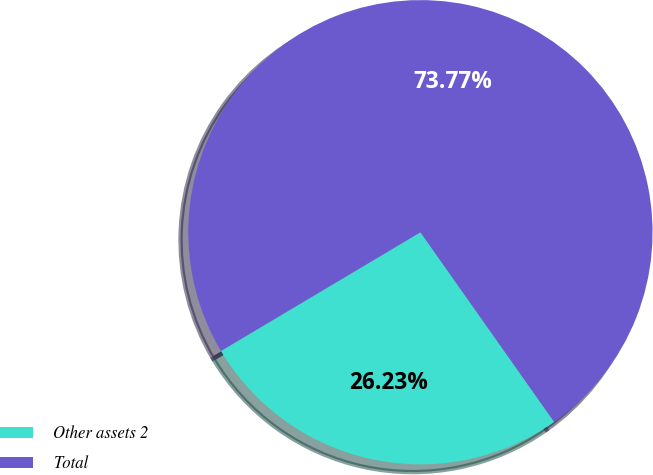<chart> <loc_0><loc_0><loc_500><loc_500><pie_chart><fcel>Other assets 2<fcel>Total<nl><fcel>26.23%<fcel>73.77%<nl></chart> 